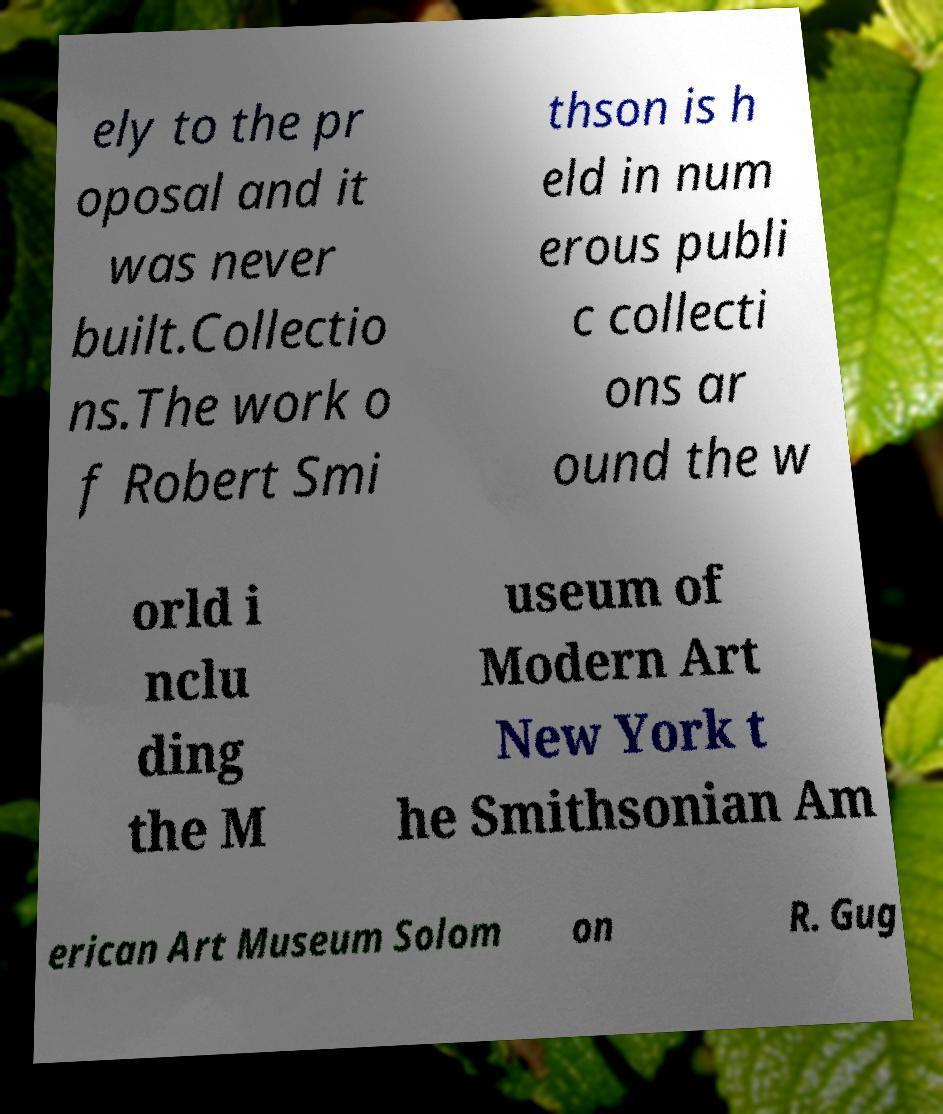Please read and relay the text visible in this image. What does it say? ely to the pr oposal and it was never built.Collectio ns.The work o f Robert Smi thson is h eld in num erous publi c collecti ons ar ound the w orld i nclu ding the M useum of Modern Art New York t he Smithsonian Am erican Art Museum Solom on R. Gug 